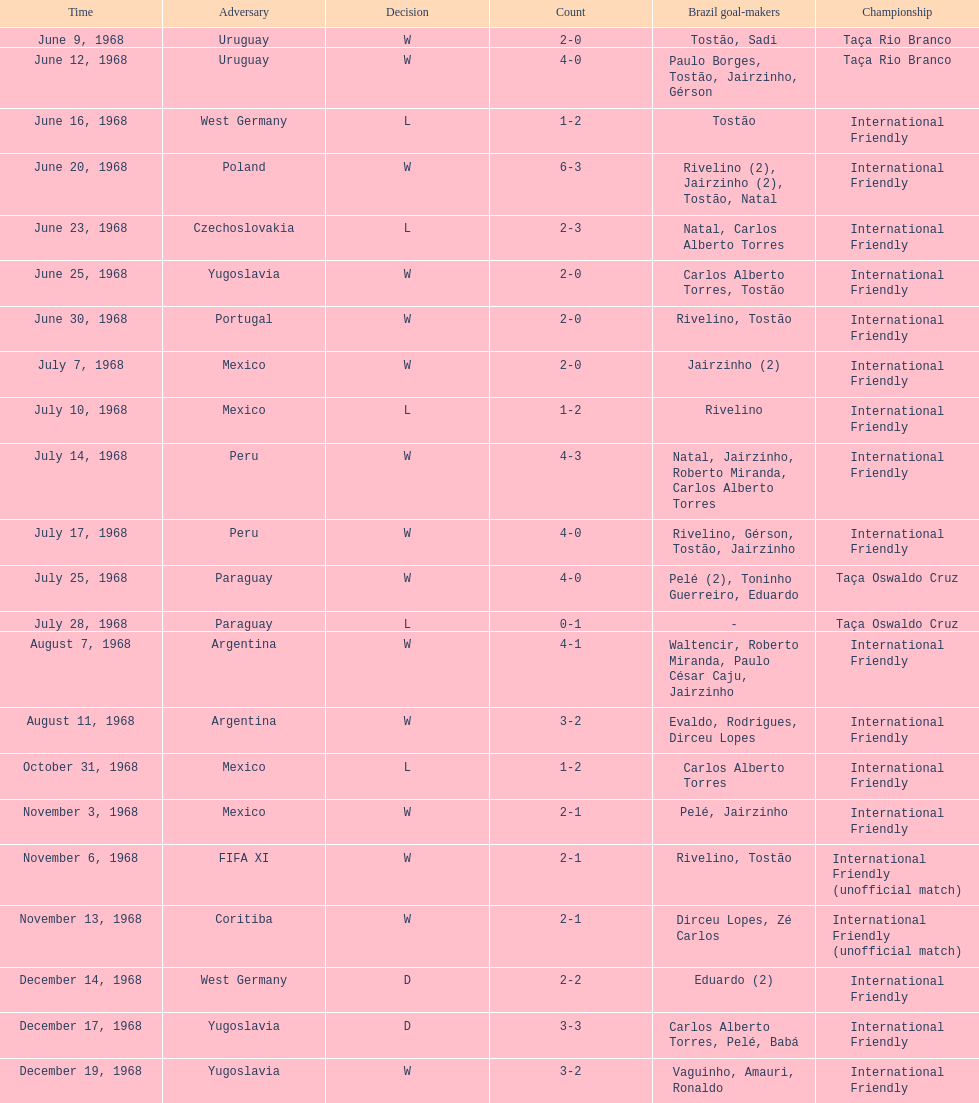Number of losses 5. 